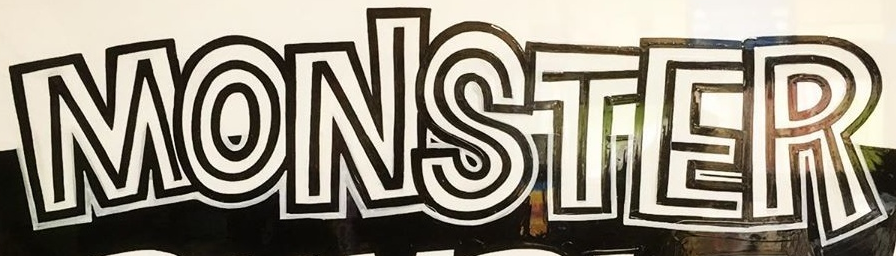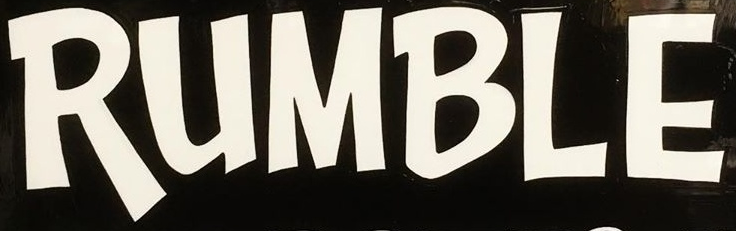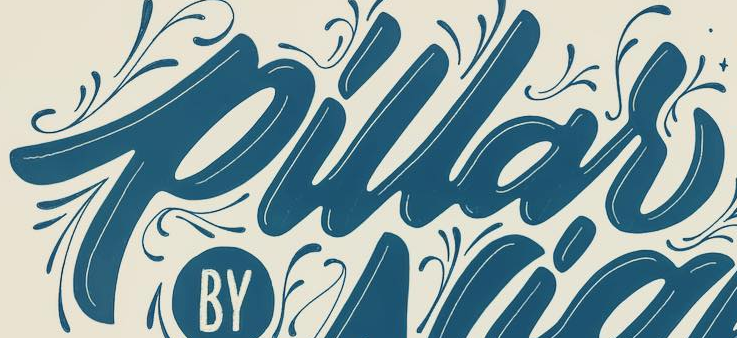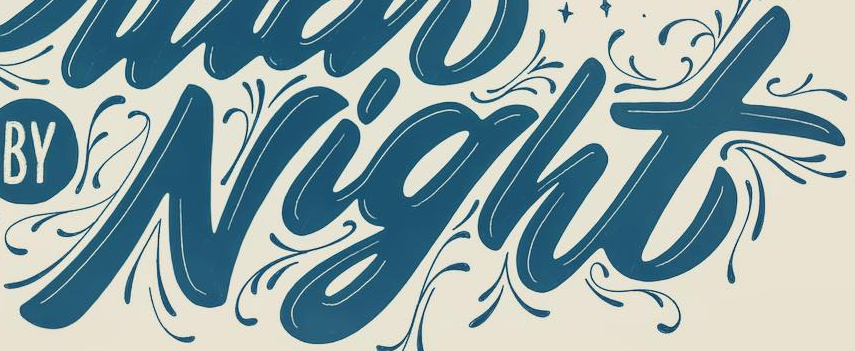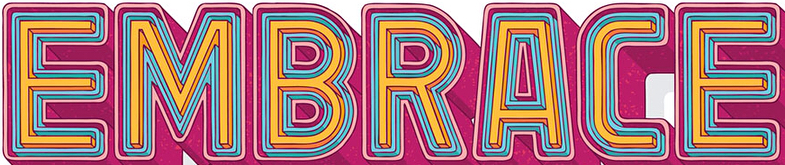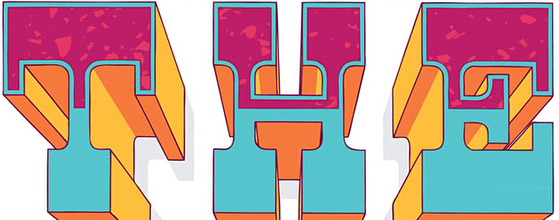What text appears in these images from left to right, separated by a semicolon? MONSTER; RUMBLE; pillar; Night; EMBRACE; THE 